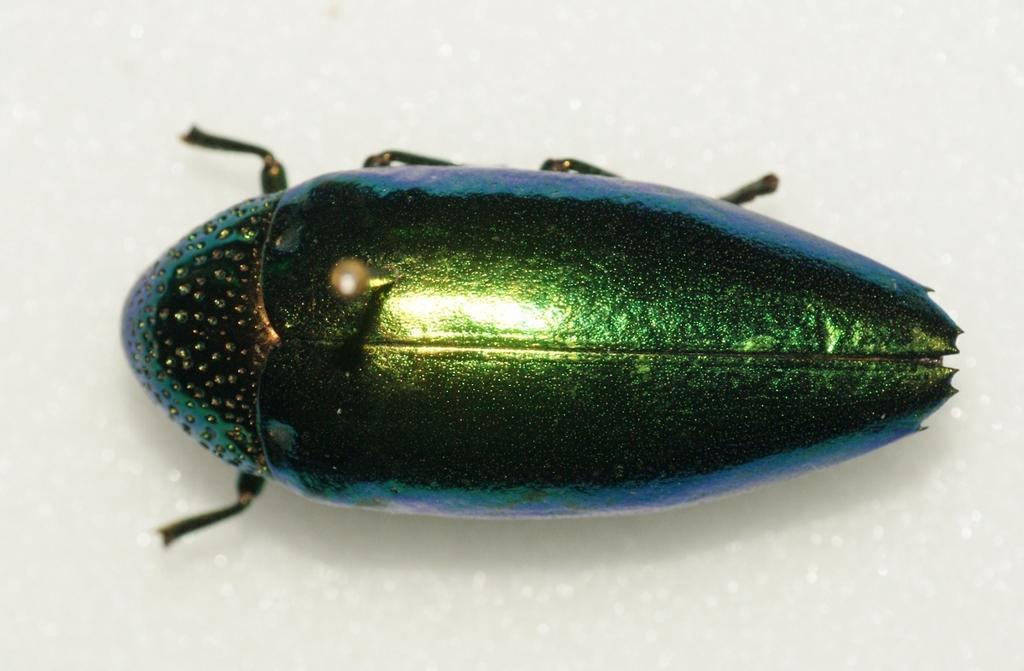What type of creature can be seen in the image? There is an insect in the image. What color is the background of the image? The background of the image is white. How does the insect help people in the image? The image does not show the insect helping people; it only depicts the insect itself. 